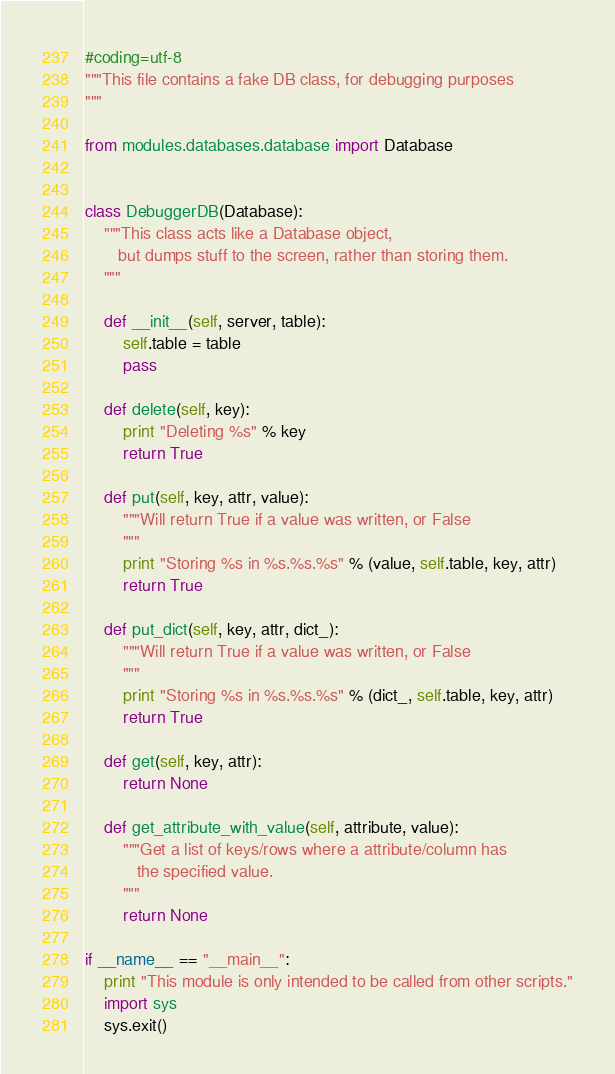<code> <loc_0><loc_0><loc_500><loc_500><_Python_>#coding=utf-8
"""This file contains a fake DB class, for debugging purposes
"""

from modules.databases.database import Database


class DebuggerDB(Database):
    """This class acts like a Database object,
       but dumps stuff to the screen, rather than storing them.
    """

    def __init__(self, server, table):
        self.table = table
        pass

    def delete(self, key):
        print "Deleting %s" % key
        return True

    def put(self, key, attr, value):
        """Will return True if a value was written, or False
        """
        print "Storing %s in %s.%s.%s" % (value, self.table, key, attr)
        return True

    def put_dict(self, key, attr, dict_):
        """Will return True if a value was written, or False
        """
        print "Storing %s in %s.%s.%s" % (dict_, self.table, key, attr)
        return True

    def get(self, key, attr):
        return None

    def get_attribute_with_value(self, attribute, value):
        """Get a list of keys/rows where a attribute/column has
           the specified value.
        """
        return None

if __name__ == "__main__":
    print "This module is only intended to be called from other scripts."
    import sys
    sys.exit()
</code> 